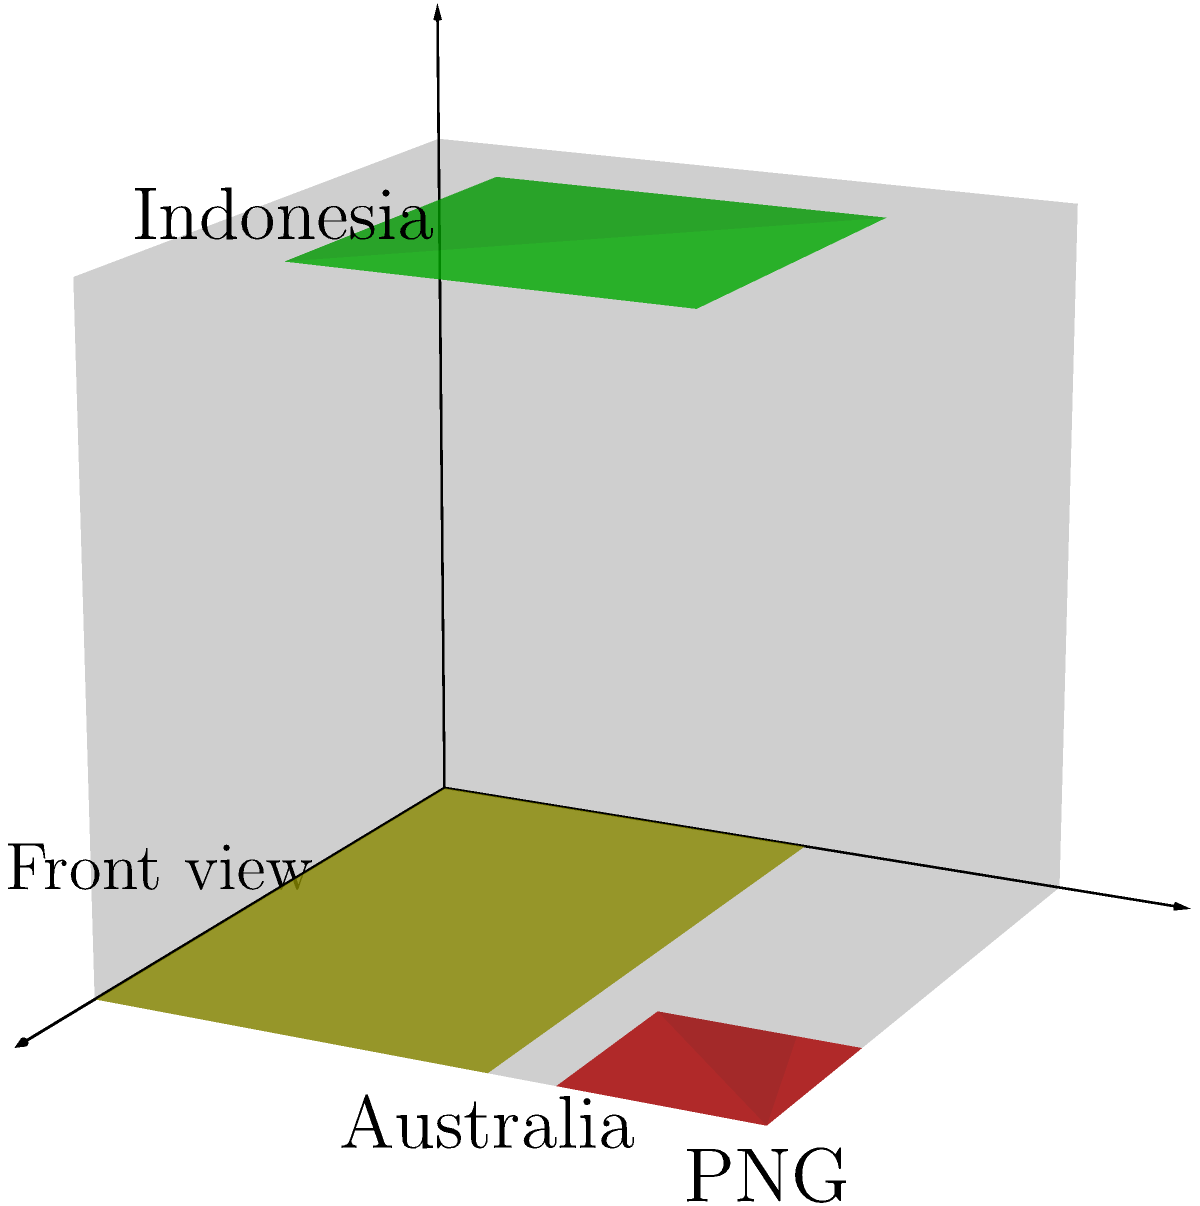The image shows a 3D political map of Indonesia and its neighboring countries. If this cube is rotated 90 degrees clockwise around the vertical axis, which country would be visible on the right face of the cube? To solve this problem, let's follow these steps:

1. Understand the current orientation:
   - Indonesia is on the top face
   - Australia is on the front face
   - Papua New Guinea (PNG) is on the front face, top-right corner

2. Visualize the rotation:
   - A 90-degree clockwise rotation around the vertical axis means the right face will become the front face

3. Identify the right face in the current orientation:
   - The right face is not visible in the given image
   - However, we know that in a cube, the right face is opposite to the left face

4. Deduce what's on the right face:
   - Since Indonesia covers most of the top face and extends to the edges, it's likely that Indonesia continues onto the right face of the cube

5. Confirm the answer:
   - Indonesia is an archipelagic country that spans a wide area, making it the most probable country to appear on multiple faces of the cube

Therefore, after the rotation, Indonesia would be visible on the new front face (previously the right face) of the cube.
Answer: Indonesia 